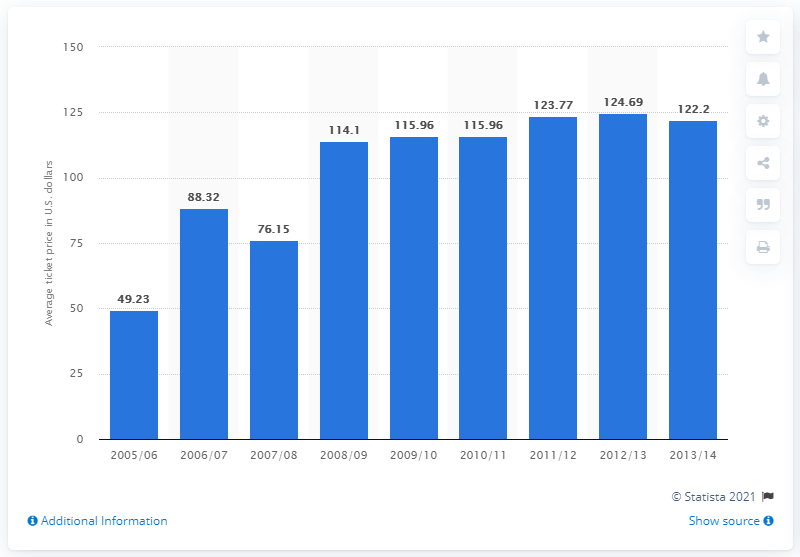Highlight a few significant elements in this photo. The average ticket price in the 2005/06 season was 49.23 dollars. 